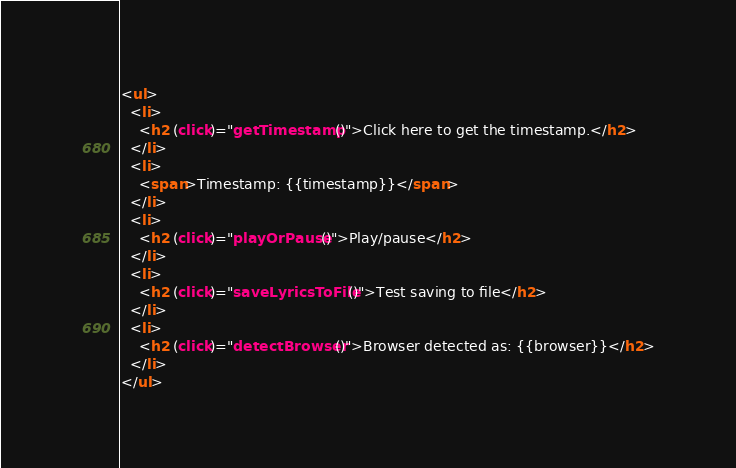<code> <loc_0><loc_0><loc_500><loc_500><_HTML_><ul>
  <li>
    <h2 (click)="getTimestamp()">Click here to get the timestamp.</h2>
  </li>
  <li>
    <span>Timestamp: {{timestamp}}</span>
  </li>
  <li>
    <h2 (click)="playOrPause()">Play/pause</h2>
  </li>
  <li>
    <h2 (click)="saveLyricsToFile()">Test saving to file</h2>
  </li>
  <li>
    <h2 (click)="detectBrowser()">Browser detected as: {{browser}}</h2>
  </li>
</ul>
</code> 